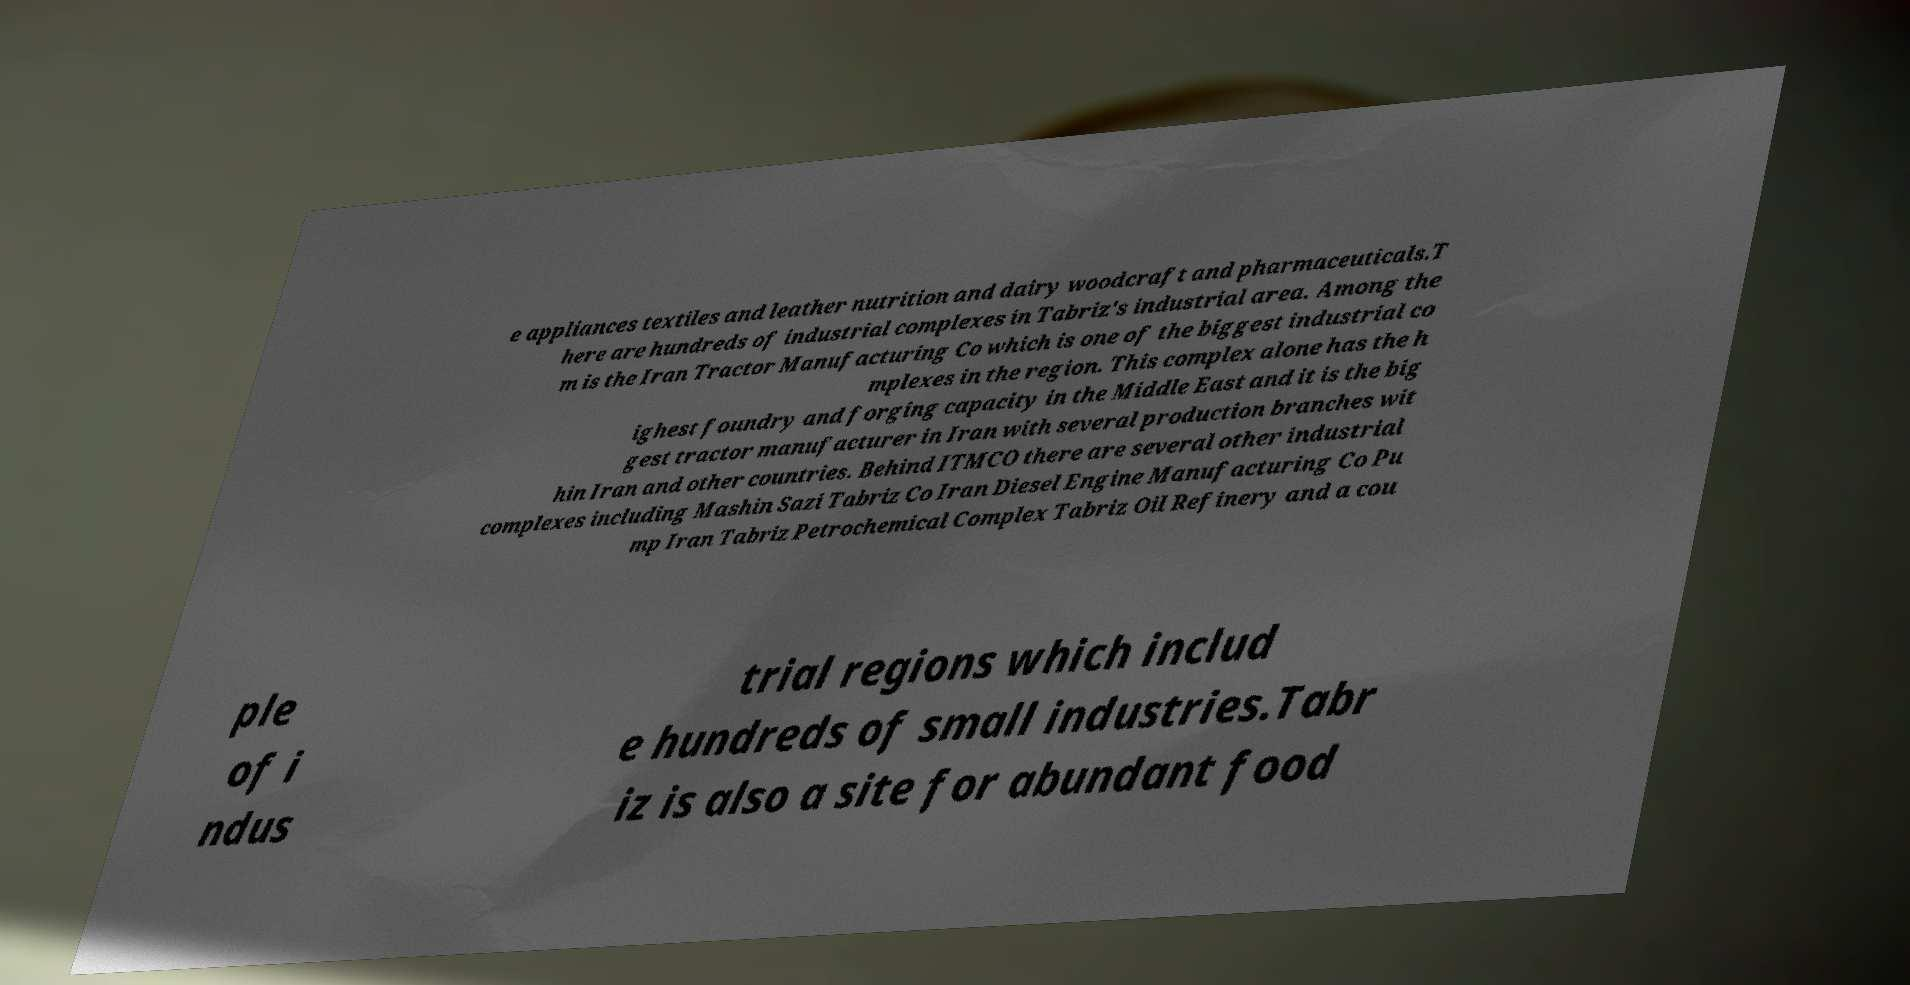Please read and relay the text visible in this image. What does it say? e appliances textiles and leather nutrition and dairy woodcraft and pharmaceuticals.T here are hundreds of industrial complexes in Tabriz's industrial area. Among the m is the Iran Tractor Manufacturing Co which is one of the biggest industrial co mplexes in the region. This complex alone has the h ighest foundry and forging capacity in the Middle East and it is the big gest tractor manufacturer in Iran with several production branches wit hin Iran and other countries. Behind ITMCO there are several other industrial complexes including Mashin Sazi Tabriz Co Iran Diesel Engine Manufacturing Co Pu mp Iran Tabriz Petrochemical Complex Tabriz Oil Refinery and a cou ple of i ndus trial regions which includ e hundreds of small industries.Tabr iz is also a site for abundant food 